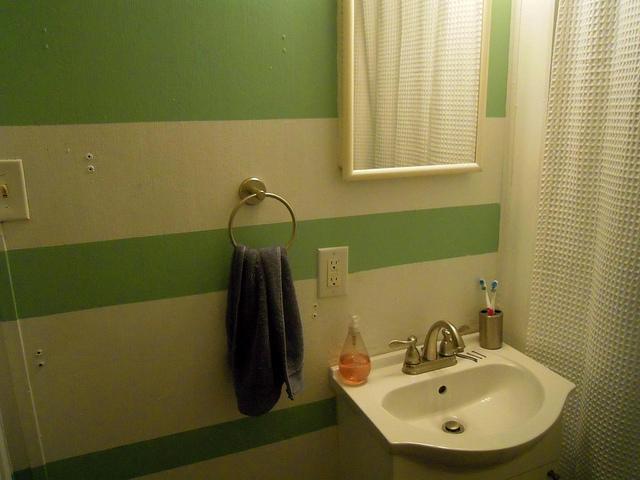How many toothbrushes are there in the cup?
Give a very brief answer. 2. How many towels are hanging not folded?
Give a very brief answer. 1. How many people are holding a remote controller?
Give a very brief answer. 0. 